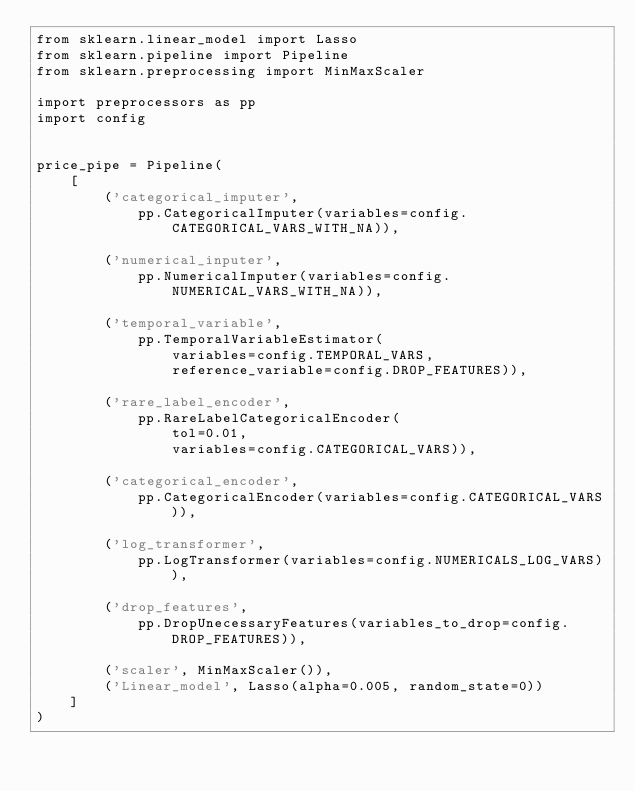<code> <loc_0><loc_0><loc_500><loc_500><_Python_>from sklearn.linear_model import Lasso
from sklearn.pipeline import Pipeline
from sklearn.preprocessing import MinMaxScaler

import preprocessors as pp
import config


price_pipe = Pipeline(
    [
        ('categorical_imputer',
            pp.CategoricalImputer(variables=config.CATEGORICAL_VARS_WITH_NA)),
         
        ('numerical_inputer',
            pp.NumericalImputer(variables=config.NUMERICAL_VARS_WITH_NA)),
         
        ('temporal_variable',
            pp.TemporalVariableEstimator(
                variables=config.TEMPORAL_VARS,
                reference_variable=config.DROP_FEATURES)),
         
        ('rare_label_encoder',
            pp.RareLabelCategoricalEncoder(
                tol=0.01,
                variables=config.CATEGORICAL_VARS)),
         
        ('categorical_encoder',
            pp.CategoricalEncoder(variables=config.CATEGORICAL_VARS)),
         
        ('log_transformer',
            pp.LogTransformer(variables=config.NUMERICALS_LOG_VARS)),
         
        ('drop_features',
            pp.DropUnecessaryFeatures(variables_to_drop=config.DROP_FEATURES)),
         
        ('scaler', MinMaxScaler()),
        ('Linear_model', Lasso(alpha=0.005, random_state=0))
    ]
)
</code> 